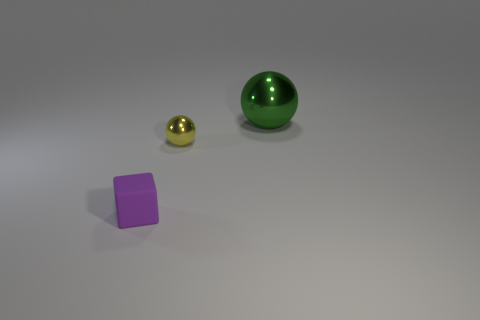Is there anything else that has the same material as the small cube?
Offer a terse response. No. What is the material of the purple thing that is the same size as the yellow metallic object?
Your answer should be compact. Rubber. What number of other objects are there of the same material as the tiny purple thing?
Offer a very short reply. 0. Is the shape of the metallic thing right of the tiny yellow metal object the same as the tiny thing that is right of the purple block?
Provide a short and direct response. Yes. How many other objects are there of the same color as the small ball?
Provide a short and direct response. 0. Are the sphere left of the big green shiny ball and the purple block that is to the left of the green metallic thing made of the same material?
Ensure brevity in your answer.  No. Are there the same number of green balls on the left side of the green metallic sphere and large objects that are in front of the tiny yellow thing?
Provide a short and direct response. Yes. There is a sphere in front of the large shiny object; what is its material?
Your response must be concise. Metal. Is there anything else that has the same size as the yellow object?
Offer a terse response. Yes. Is the number of tiny yellow balls less than the number of small purple metal balls?
Provide a short and direct response. No. 